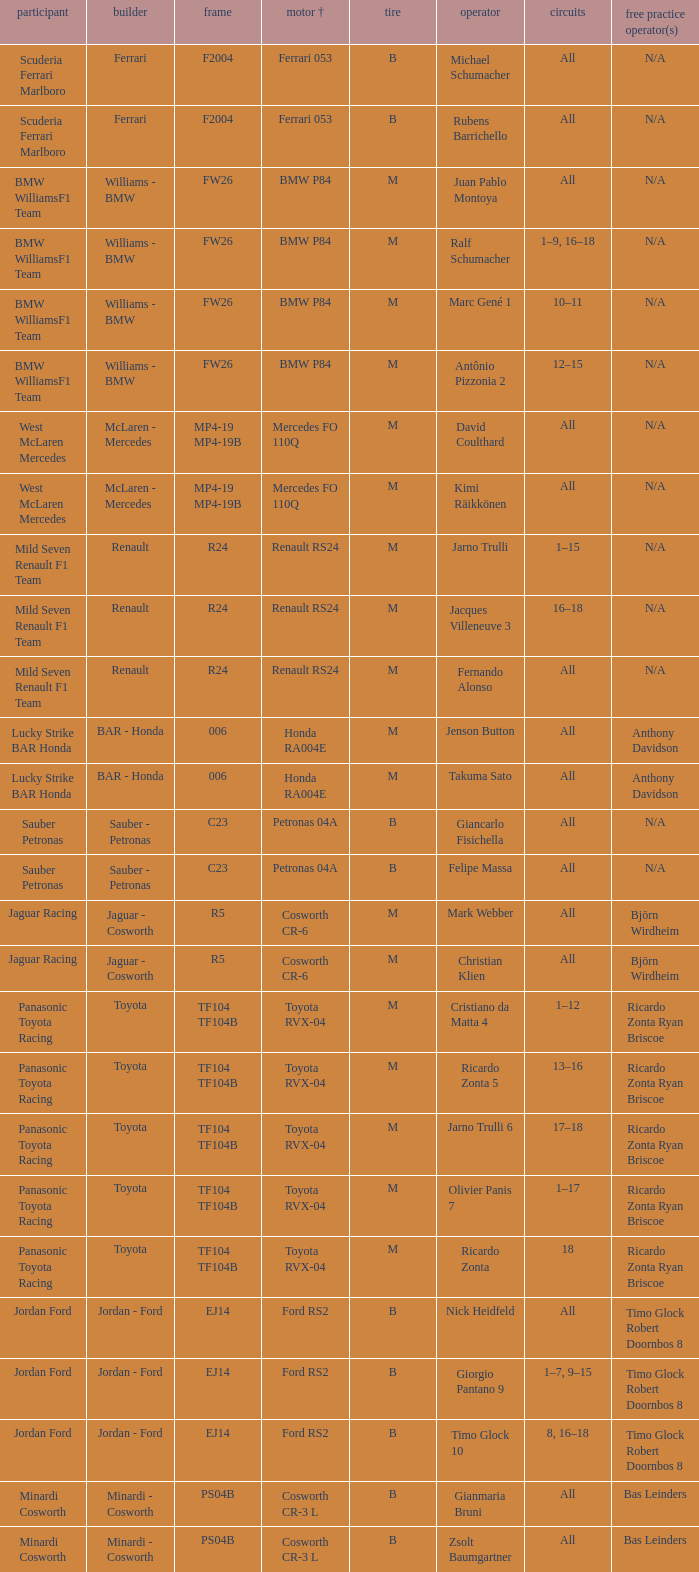What kind of chassis does Ricardo Zonta have? TF104 TF104B. 